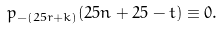<formula> <loc_0><loc_0><loc_500><loc_500>p _ { - ( 2 5 r + k ) } ( 2 5 n + 2 5 - t ) \equiv 0 .</formula> 